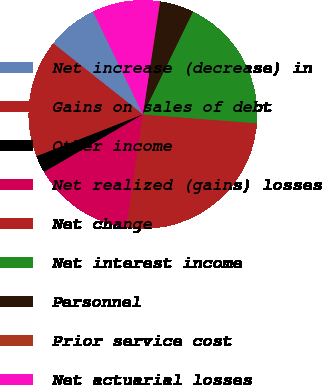Convert chart. <chart><loc_0><loc_0><loc_500><loc_500><pie_chart><fcel>Net increase (decrease) in<fcel>Gains on sales of debt<fcel>Other income<fcel>Net realized (gains) losses<fcel>Net change<fcel>Net interest income<fcel>Personnel<fcel>Prior service cost<fcel>Net actuarial losses<nl><fcel>7.16%<fcel>16.64%<fcel>2.43%<fcel>14.27%<fcel>26.11%<fcel>19.01%<fcel>4.8%<fcel>0.06%<fcel>9.53%<nl></chart> 